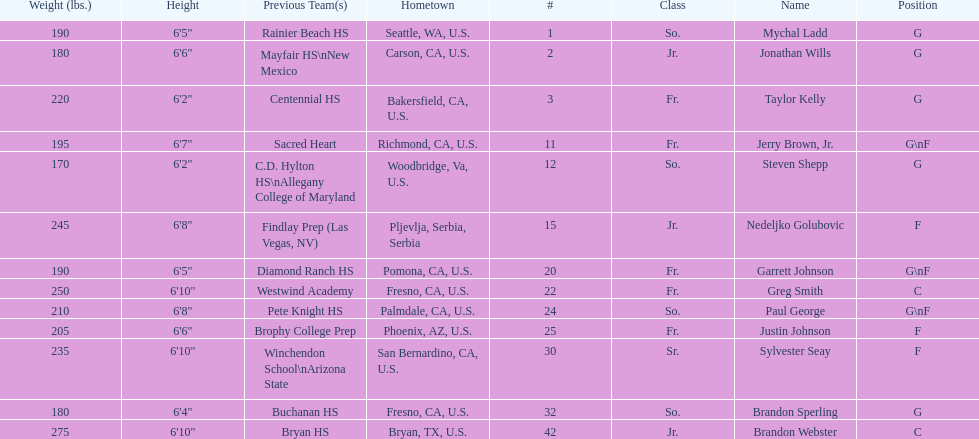How many players hometowns are outside of california? 5. 